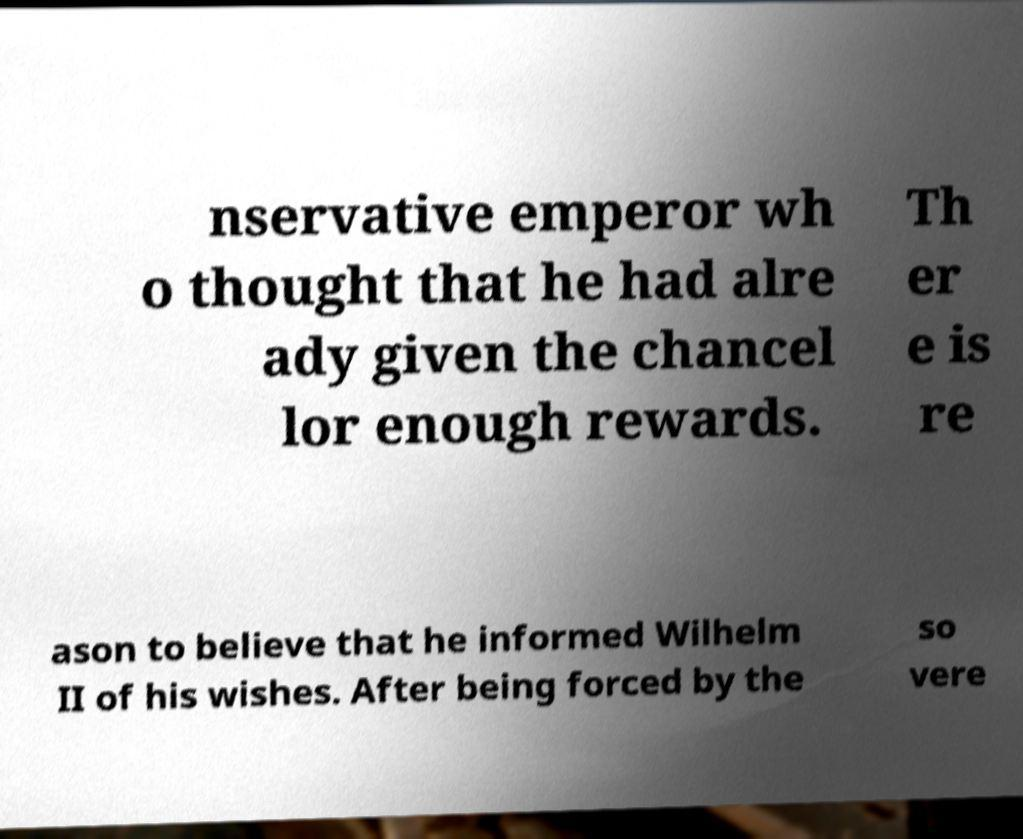Could you extract and type out the text from this image? nservative emperor wh o thought that he had alre ady given the chancel lor enough rewards. Th er e is re ason to believe that he informed Wilhelm II of his wishes. After being forced by the so vere 